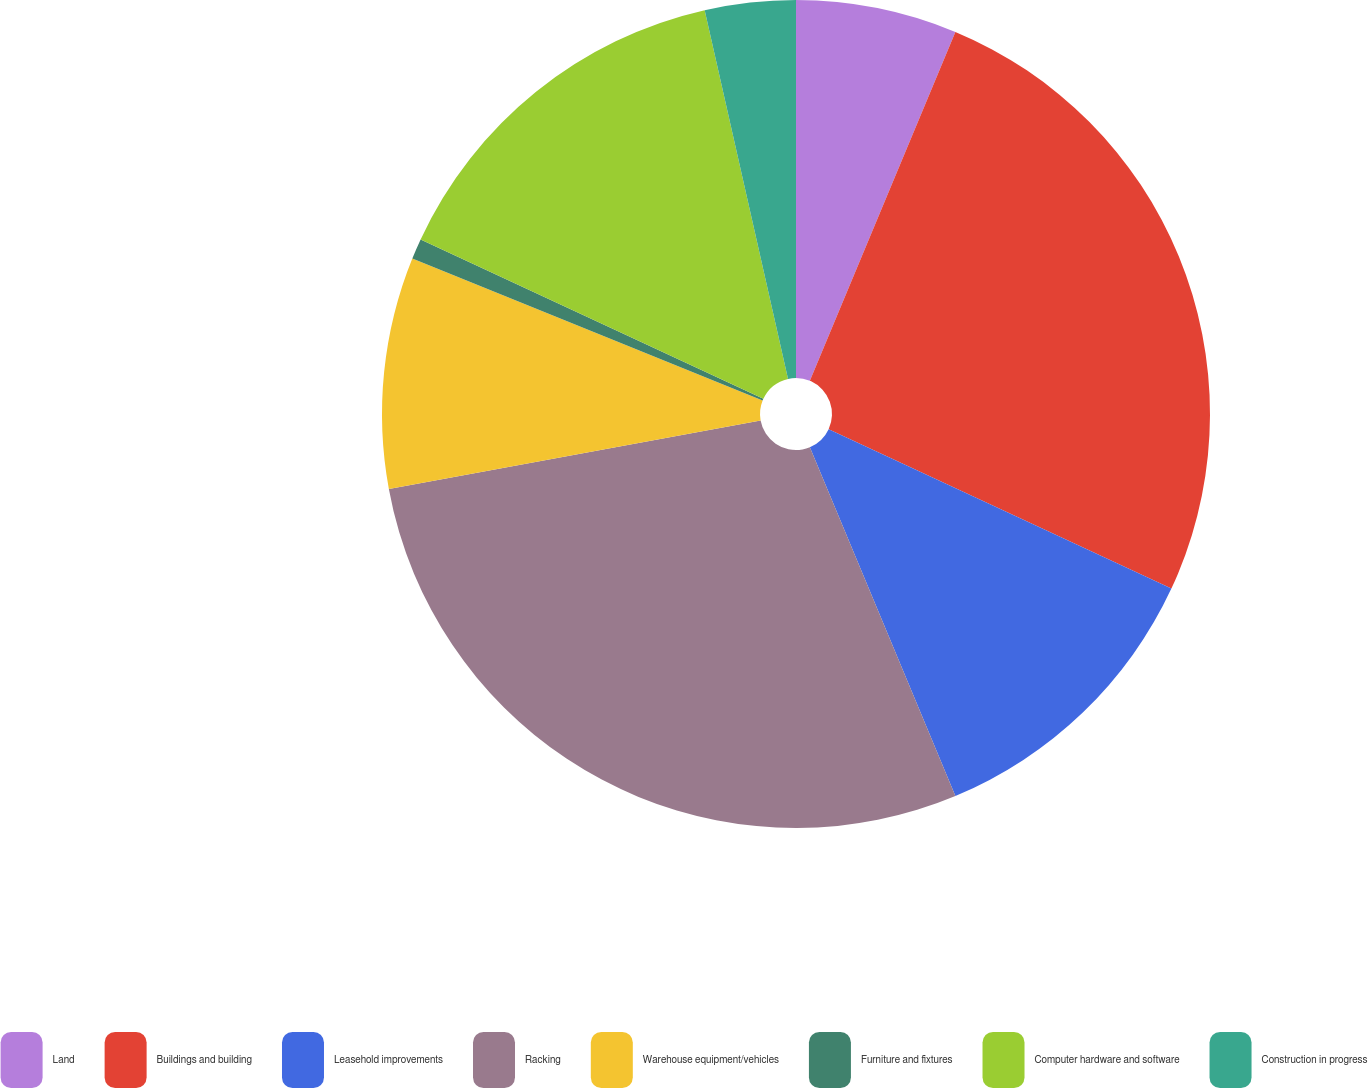Convert chart to OTSL. <chart><loc_0><loc_0><loc_500><loc_500><pie_chart><fcel>Land<fcel>Buildings and building<fcel>Leasehold improvements<fcel>Racking<fcel>Warehouse equipment/vehicles<fcel>Furniture and fixtures<fcel>Computer hardware and software<fcel>Construction in progress<nl><fcel>6.29%<fcel>25.64%<fcel>11.78%<fcel>28.39%<fcel>9.03%<fcel>0.8%<fcel>14.53%<fcel>3.54%<nl></chart> 